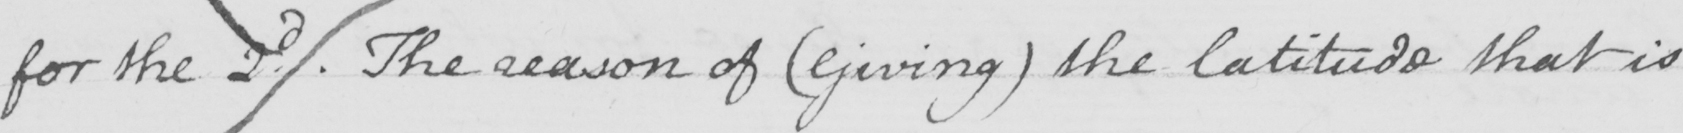Can you read and transcribe this handwriting? for the 2d . The reason of  ( Giving )  the latitude that is 